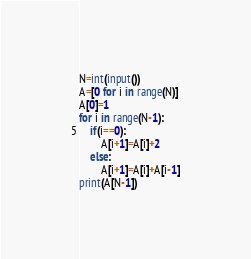Convert code to text. <code><loc_0><loc_0><loc_500><loc_500><_Python_>N=int(input())
A=[0 for i in range(N)]
A[0]=1
for i in range(N-1):
    if(i==0):
        A[i+1]=A[i]+2
    else:
        A[i+1]=A[i]+A[i-1]
print(A[N-1])
</code> 